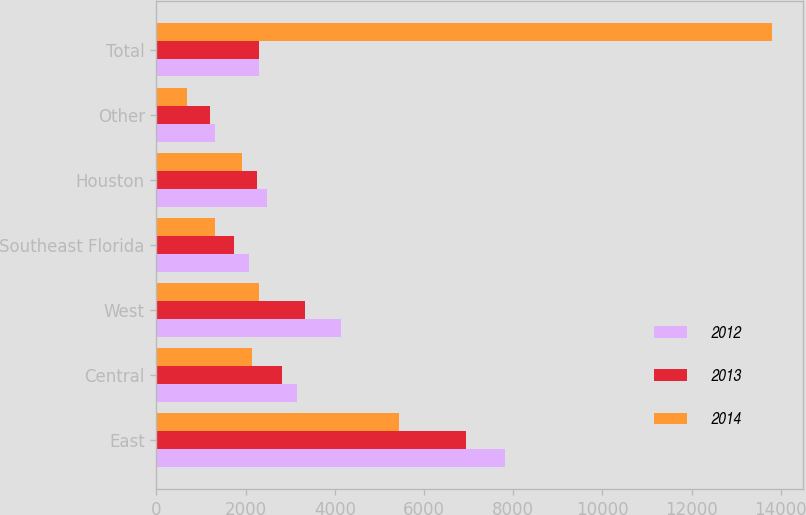Convert chart to OTSL. <chart><loc_0><loc_0><loc_500><loc_500><stacked_bar_chart><ecel><fcel>East<fcel>Central<fcel>West<fcel>Southeast Florida<fcel>Houston<fcel>Other<fcel>Total<nl><fcel>2012<fcel>7824<fcel>3156<fcel>4141<fcel>2086<fcel>2482<fcel>1314<fcel>2301<nl><fcel>2013<fcel>6941<fcel>2814<fcel>3323<fcel>1741<fcel>2266<fcel>1205<fcel>2301<nl><fcel>2014<fcel>5440<fcel>2154<fcel>2301<fcel>1314<fcel>1917<fcel>676<fcel>13802<nl></chart> 